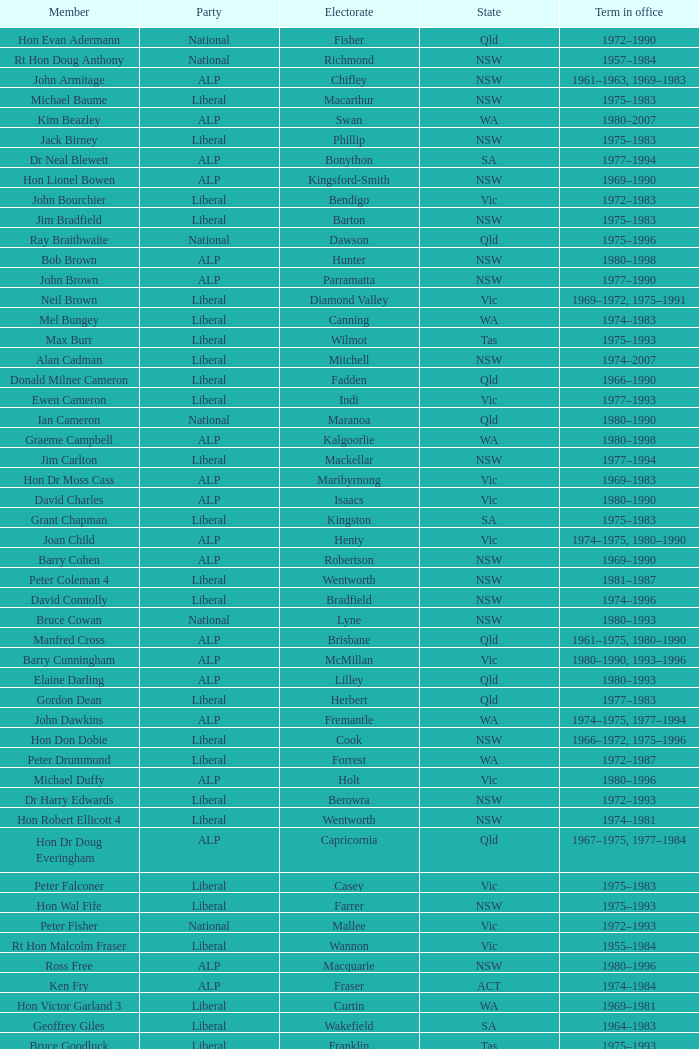What party is Mick Young a member of? ALP. 